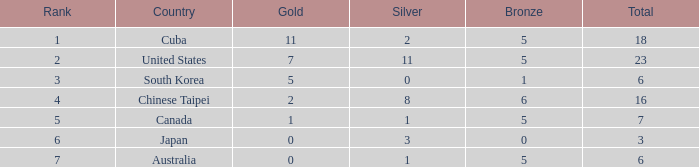What is the combined amount of the bronze medals when there were more than 2 silver medals and a ranking above 6? None. 